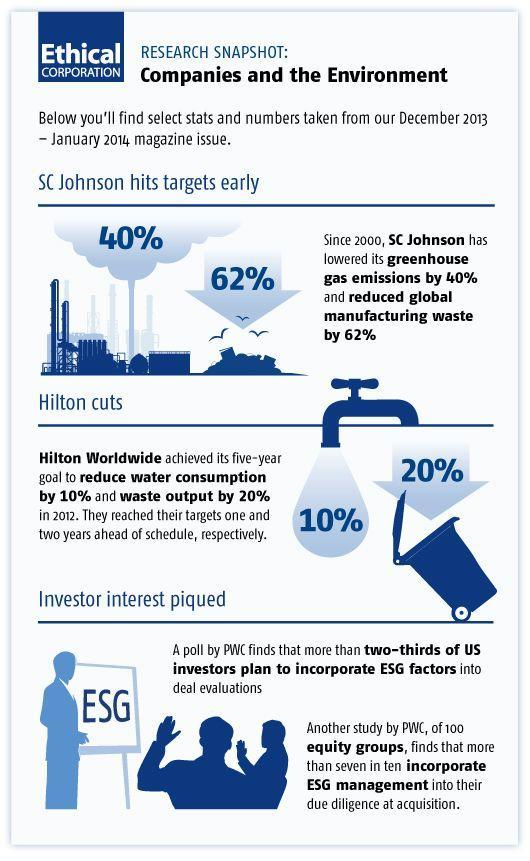What is written on the board?
Answer the question with a short phrase. ESG 